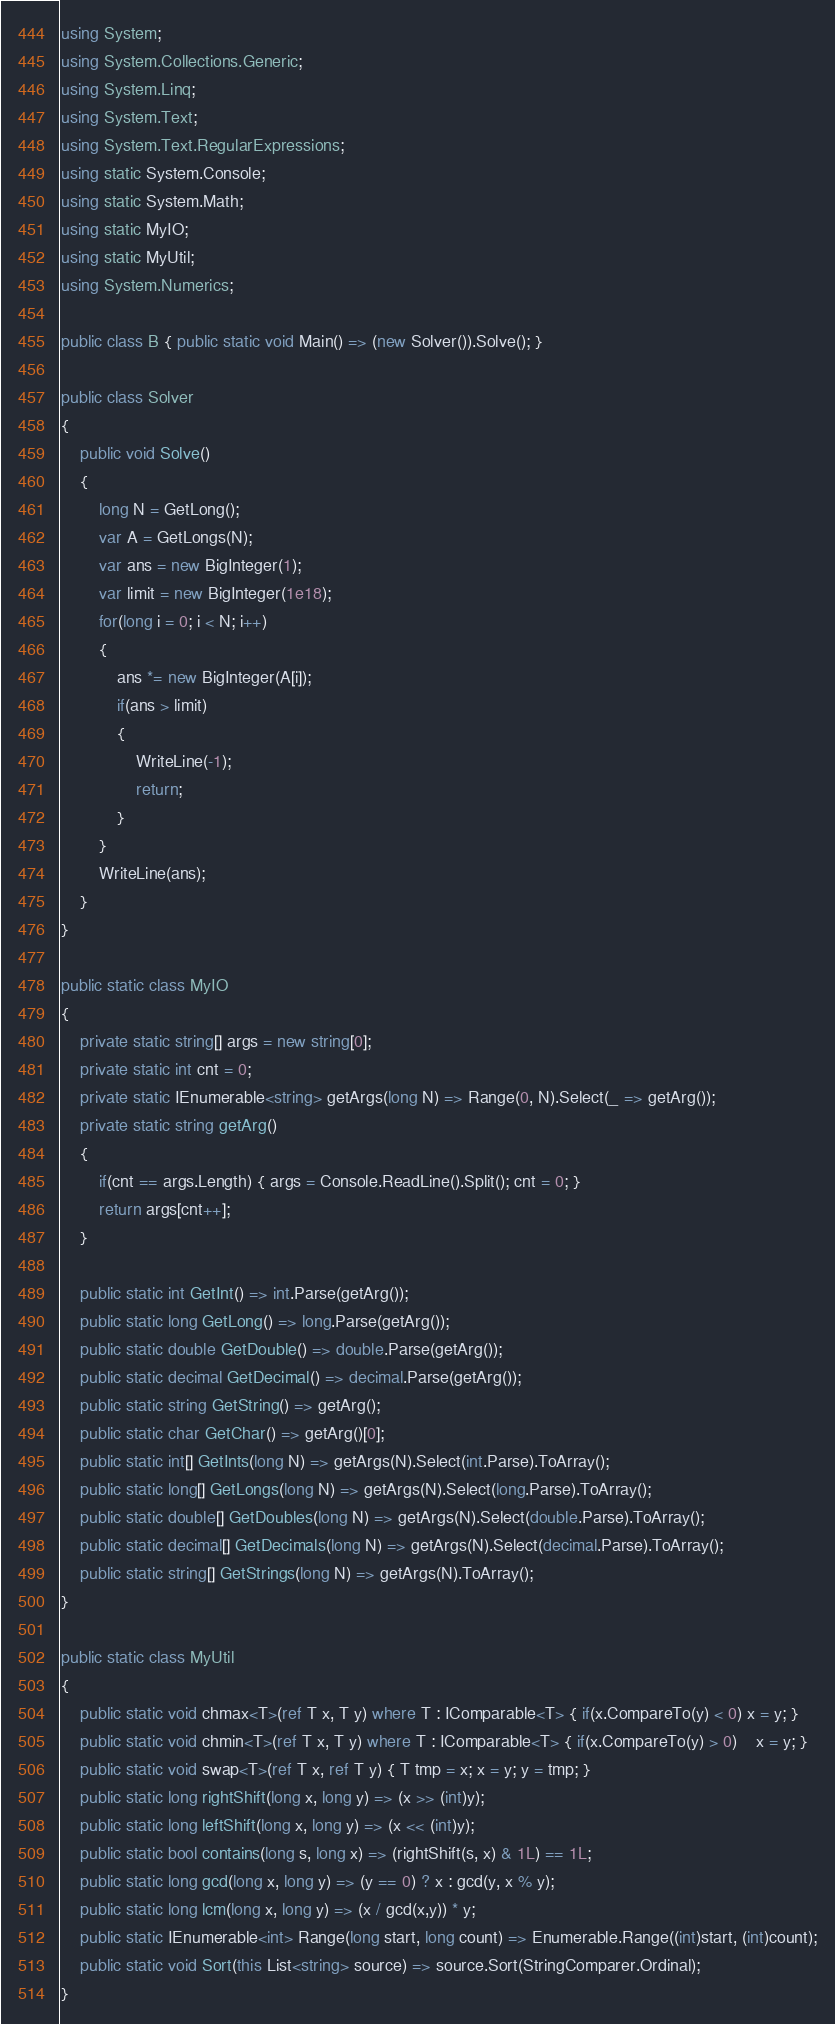<code> <loc_0><loc_0><loc_500><loc_500><_C#_>using System;
using System.Collections.Generic;
using System.Linq;
using System.Text;
using System.Text.RegularExpressions;
using static System.Console;
using static System.Math;
using static MyIO;
using static MyUtil;
using System.Numerics;

public class B { public static void Main() => (new Solver()).Solve(); }

public class Solver
{
	public void Solve()
	{
		long N = GetLong();
		var A = GetLongs(N);
		var ans = new BigInteger(1);
		var limit = new BigInteger(1e18);
		for(long i = 0; i < N; i++)
		{
			ans *= new BigInteger(A[i]);
			if(ans > limit)
			{
				WriteLine(-1);
				return;
			}
		}
		WriteLine(ans);
	}
}

public static class MyIO
{
	private static string[] args = new string[0];
	private static int cnt = 0;
	private static IEnumerable<string> getArgs(long N) => Range(0, N).Select(_ => getArg());
	private static string getArg()
	{
		if(cnt == args.Length) { args = Console.ReadLine().Split(); cnt = 0; }
		return args[cnt++];
	}

	public static int GetInt() => int.Parse(getArg());
	public static long GetLong() => long.Parse(getArg());
	public static double GetDouble() => double.Parse(getArg());
	public static decimal GetDecimal() => decimal.Parse(getArg());
	public static string GetString() => getArg();
	public static char GetChar() => getArg()[0];
	public static int[] GetInts(long N) => getArgs(N).Select(int.Parse).ToArray();
	public static long[] GetLongs(long N) => getArgs(N).Select(long.Parse).ToArray();
	public static double[] GetDoubles(long N) => getArgs(N).Select(double.Parse).ToArray();
	public static decimal[] GetDecimals(long N) => getArgs(N).Select(decimal.Parse).ToArray();
	public static string[] GetStrings(long N) => getArgs(N).ToArray();
}

public static class MyUtil
{
	public static void chmax<T>(ref T x, T y) where T : IComparable<T> { if(x.CompareTo(y) < 0) x = y; }
	public static void chmin<T>(ref T x, T y) where T : IComparable<T> { if(x.CompareTo(y) > 0)	x = y; }
	public static void swap<T>(ref T x, ref T y) { T tmp = x; x = y; y = tmp; }
	public static long rightShift(long x, long y) => (x >> (int)y);
	public static long leftShift(long x, long y) => (x << (int)y);
	public static bool contains(long s, long x) => (rightShift(s, x) & 1L) == 1L;
	public static long gcd(long x, long y) => (y == 0) ? x : gcd(y, x % y);
	public static long lcm(long x, long y) => (x / gcd(x,y)) * y;	
	public static IEnumerable<int> Range(long start, long count) => Enumerable.Range((int)start, (int)count);
	public static void Sort(this List<string> source) => source.Sort(StringComparer.Ordinal);
}
</code> 